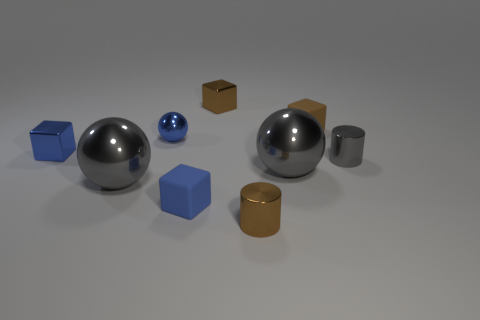Add 1 large gray metal objects. How many objects exist? 10 Subtract all blocks. How many objects are left? 5 Add 7 brown metallic blocks. How many brown metallic blocks are left? 8 Add 3 small green balls. How many small green balls exist? 3 Subtract 0 green spheres. How many objects are left? 9 Subtract all gray spheres. Subtract all blue objects. How many objects are left? 4 